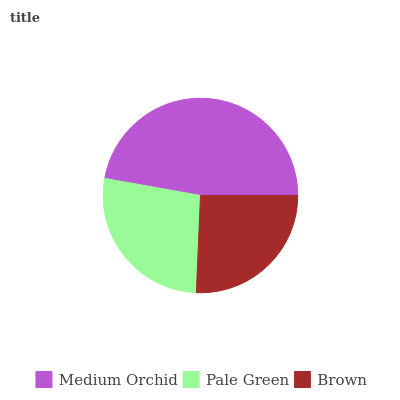Is Brown the minimum?
Answer yes or no. Yes. Is Medium Orchid the maximum?
Answer yes or no. Yes. Is Pale Green the minimum?
Answer yes or no. No. Is Pale Green the maximum?
Answer yes or no. No. Is Medium Orchid greater than Pale Green?
Answer yes or no. Yes. Is Pale Green less than Medium Orchid?
Answer yes or no. Yes. Is Pale Green greater than Medium Orchid?
Answer yes or no. No. Is Medium Orchid less than Pale Green?
Answer yes or no. No. Is Pale Green the high median?
Answer yes or no. Yes. Is Pale Green the low median?
Answer yes or no. Yes. Is Brown the high median?
Answer yes or no. No. Is Brown the low median?
Answer yes or no. No. 